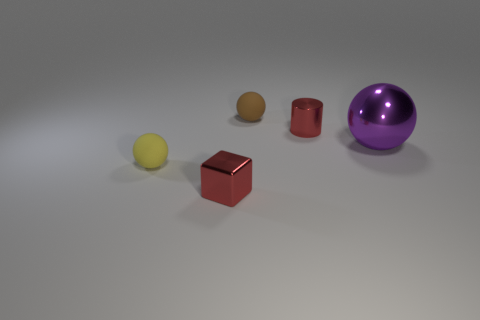Add 3 cyan rubber cylinders. How many objects exist? 8 Subtract all blocks. How many objects are left? 4 Add 5 tiny cylinders. How many tiny cylinders are left? 6 Add 4 blocks. How many blocks exist? 5 Subtract 0 yellow cylinders. How many objects are left? 5 Subtract all small metallic objects. Subtract all cubes. How many objects are left? 2 